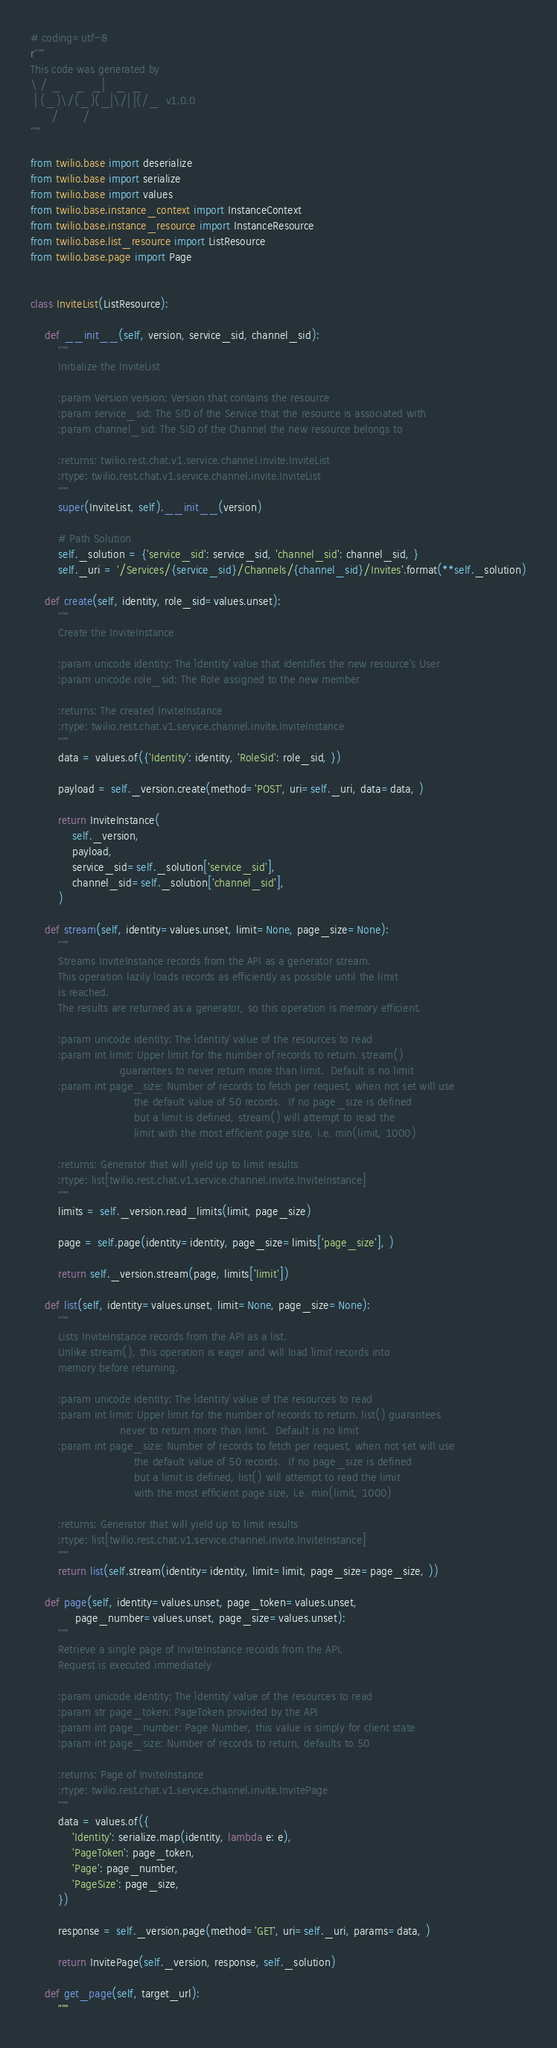Convert code to text. <code><loc_0><loc_0><loc_500><loc_500><_Python_># coding=utf-8
r"""
This code was generated by
\ / _    _  _|   _  _
 | (_)\/(_)(_|\/| |(/_  v1.0.0
      /       /
"""

from twilio.base import deserialize
from twilio.base import serialize
from twilio.base import values
from twilio.base.instance_context import InstanceContext
from twilio.base.instance_resource import InstanceResource
from twilio.base.list_resource import ListResource
from twilio.base.page import Page


class InviteList(ListResource):

    def __init__(self, version, service_sid, channel_sid):
        """
        Initialize the InviteList

        :param Version version: Version that contains the resource
        :param service_sid: The SID of the Service that the resource is associated with
        :param channel_sid: The SID of the Channel the new resource belongs to

        :returns: twilio.rest.chat.v1.service.channel.invite.InviteList
        :rtype: twilio.rest.chat.v1.service.channel.invite.InviteList
        """
        super(InviteList, self).__init__(version)

        # Path Solution
        self._solution = {'service_sid': service_sid, 'channel_sid': channel_sid, }
        self._uri = '/Services/{service_sid}/Channels/{channel_sid}/Invites'.format(**self._solution)

    def create(self, identity, role_sid=values.unset):
        """
        Create the InviteInstance

        :param unicode identity: The `identity` value that identifies the new resource's User
        :param unicode role_sid: The Role assigned to the new member

        :returns: The created InviteInstance
        :rtype: twilio.rest.chat.v1.service.channel.invite.InviteInstance
        """
        data = values.of({'Identity': identity, 'RoleSid': role_sid, })

        payload = self._version.create(method='POST', uri=self._uri, data=data, )

        return InviteInstance(
            self._version,
            payload,
            service_sid=self._solution['service_sid'],
            channel_sid=self._solution['channel_sid'],
        )

    def stream(self, identity=values.unset, limit=None, page_size=None):
        """
        Streams InviteInstance records from the API as a generator stream.
        This operation lazily loads records as efficiently as possible until the limit
        is reached.
        The results are returned as a generator, so this operation is memory efficient.

        :param unicode identity: The `identity` value of the resources to read
        :param int limit: Upper limit for the number of records to return. stream()
                          guarantees to never return more than limit.  Default is no limit
        :param int page_size: Number of records to fetch per request, when not set will use
                              the default value of 50 records.  If no page_size is defined
                              but a limit is defined, stream() will attempt to read the
                              limit with the most efficient page size, i.e. min(limit, 1000)

        :returns: Generator that will yield up to limit results
        :rtype: list[twilio.rest.chat.v1.service.channel.invite.InviteInstance]
        """
        limits = self._version.read_limits(limit, page_size)

        page = self.page(identity=identity, page_size=limits['page_size'], )

        return self._version.stream(page, limits['limit'])

    def list(self, identity=values.unset, limit=None, page_size=None):
        """
        Lists InviteInstance records from the API as a list.
        Unlike stream(), this operation is eager and will load `limit` records into
        memory before returning.

        :param unicode identity: The `identity` value of the resources to read
        :param int limit: Upper limit for the number of records to return. list() guarantees
                          never to return more than limit.  Default is no limit
        :param int page_size: Number of records to fetch per request, when not set will use
                              the default value of 50 records.  If no page_size is defined
                              but a limit is defined, list() will attempt to read the limit
                              with the most efficient page size, i.e. min(limit, 1000)

        :returns: Generator that will yield up to limit results
        :rtype: list[twilio.rest.chat.v1.service.channel.invite.InviteInstance]
        """
        return list(self.stream(identity=identity, limit=limit, page_size=page_size, ))

    def page(self, identity=values.unset, page_token=values.unset,
             page_number=values.unset, page_size=values.unset):
        """
        Retrieve a single page of InviteInstance records from the API.
        Request is executed immediately

        :param unicode identity: The `identity` value of the resources to read
        :param str page_token: PageToken provided by the API
        :param int page_number: Page Number, this value is simply for client state
        :param int page_size: Number of records to return, defaults to 50

        :returns: Page of InviteInstance
        :rtype: twilio.rest.chat.v1.service.channel.invite.InvitePage
        """
        data = values.of({
            'Identity': serialize.map(identity, lambda e: e),
            'PageToken': page_token,
            'Page': page_number,
            'PageSize': page_size,
        })

        response = self._version.page(method='GET', uri=self._uri, params=data, )

        return InvitePage(self._version, response, self._solution)

    def get_page(self, target_url):
        """</code> 